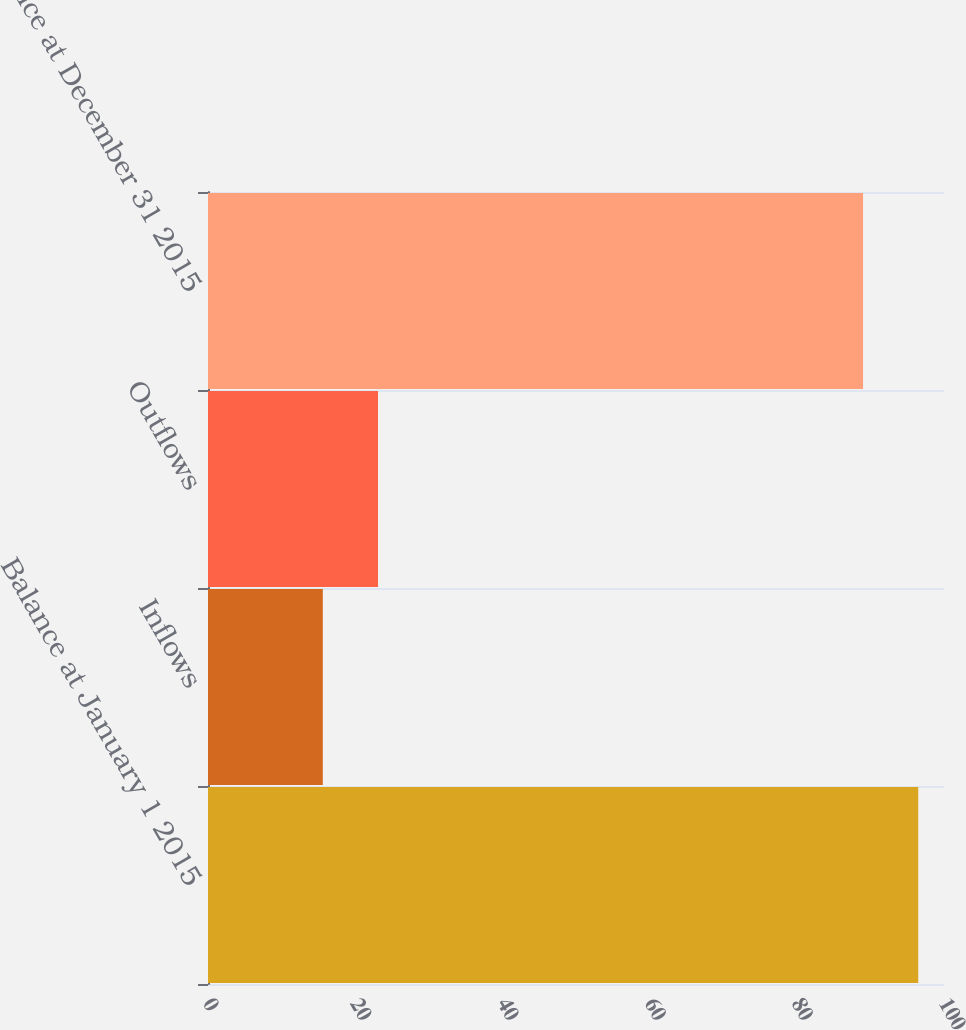Convert chart. <chart><loc_0><loc_0><loc_500><loc_500><bar_chart><fcel>Balance at January 1 2015<fcel>Inflows<fcel>Outflows<fcel>Balance at December 31 2015<nl><fcel>96.5<fcel>15.6<fcel>23.1<fcel>89<nl></chart> 